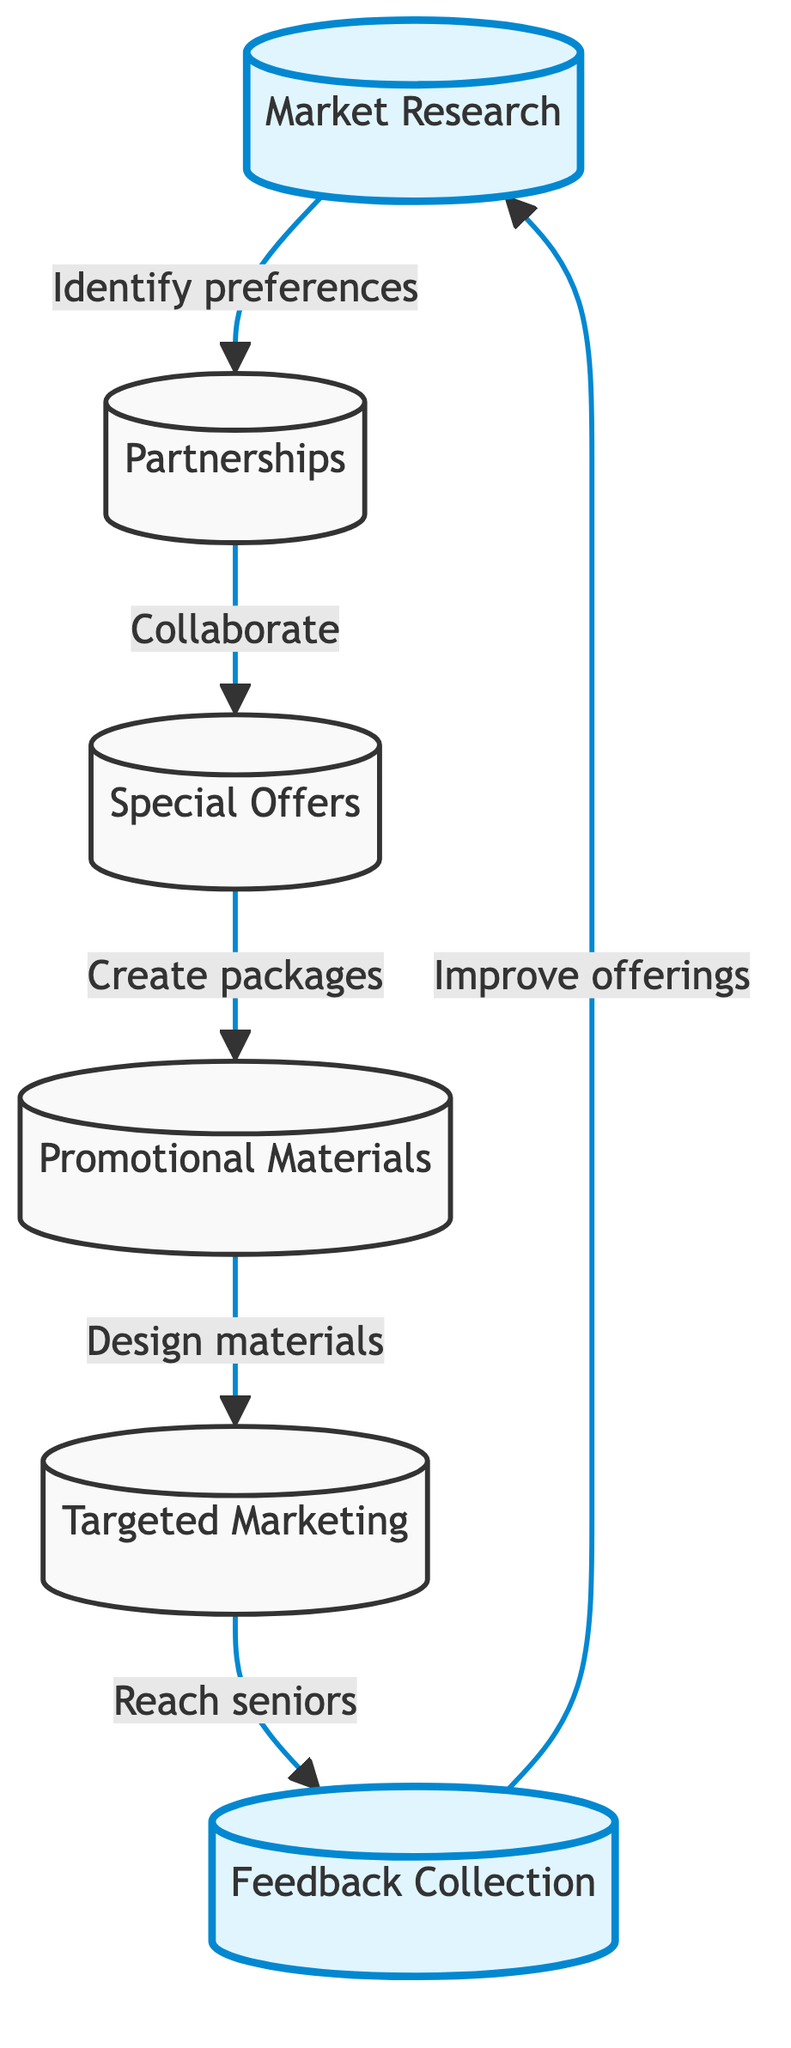What is the first step in the flow? The diagram starts with the node labeled "Market Research," which is the first step in the promotional strategy flow.
Answer: Market Research How many nodes are in the diagram? By counting all the distinct elements (Market Research, Partnerships, Special Offers, Promotional Materials, Targeted Marketing, Feedback Collection), there are a total of six nodes in the flowchart.
Answer: 6 What does "Market Research" lead to? The node labeled "Market Research" leads directly to the "Partnerships" node, showing the flow from identifying preferences to establishing collaborations.
Answer: Partnerships What is the main objective of "Feedback Collection"? The "Feedback Collection" node indicates that the purpose is to gather feedback from senior golfers so that the company can improve its offerings and customer experience.
Answer: Improve offerings What is the sequence of steps after "Special Offers"? Following "Special Offers," the next step in the sequence is "Promotional Materials," showcasing the progression from creating packages to designing marketing materials.
Answer: Promotional Materials Which node emphasizes senior-friendly services? The node labeled "Promotional Materials" focuses on designing brochures and flyers that highlight senior-friendly services, indicating the aim to attract senior golfers.
Answer: Promotional Materials What type of marketing does "Targeted Marketing" utilize? According to the diagram, "Targeted Marketing" utilizes social media and email campaigns in its strategies to reach senior golfers effectively.
Answer: Social media and email campaigns What action follows "Partnerships"? The flowchart indicates that the action following "Partnerships" is to "Create discounted golf packages" under the "Special Offers" node.
Answer: Create packages Which two nodes are highlighted in the diagram? The nodes "Market Research" and "Feedback Collection" are highlighted in the flowchart, signifying their importance in the overall travel promotion strategy.
Answer: Market Research, Feedback Collection 